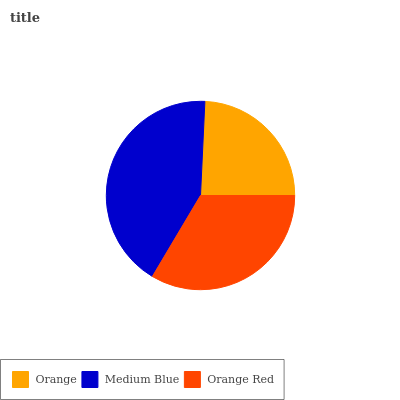Is Orange the minimum?
Answer yes or no. Yes. Is Medium Blue the maximum?
Answer yes or no. Yes. Is Orange Red the minimum?
Answer yes or no. No. Is Orange Red the maximum?
Answer yes or no. No. Is Medium Blue greater than Orange Red?
Answer yes or no. Yes. Is Orange Red less than Medium Blue?
Answer yes or no. Yes. Is Orange Red greater than Medium Blue?
Answer yes or no. No. Is Medium Blue less than Orange Red?
Answer yes or no. No. Is Orange Red the high median?
Answer yes or no. Yes. Is Orange Red the low median?
Answer yes or no. Yes. Is Medium Blue the high median?
Answer yes or no. No. Is Orange the low median?
Answer yes or no. No. 